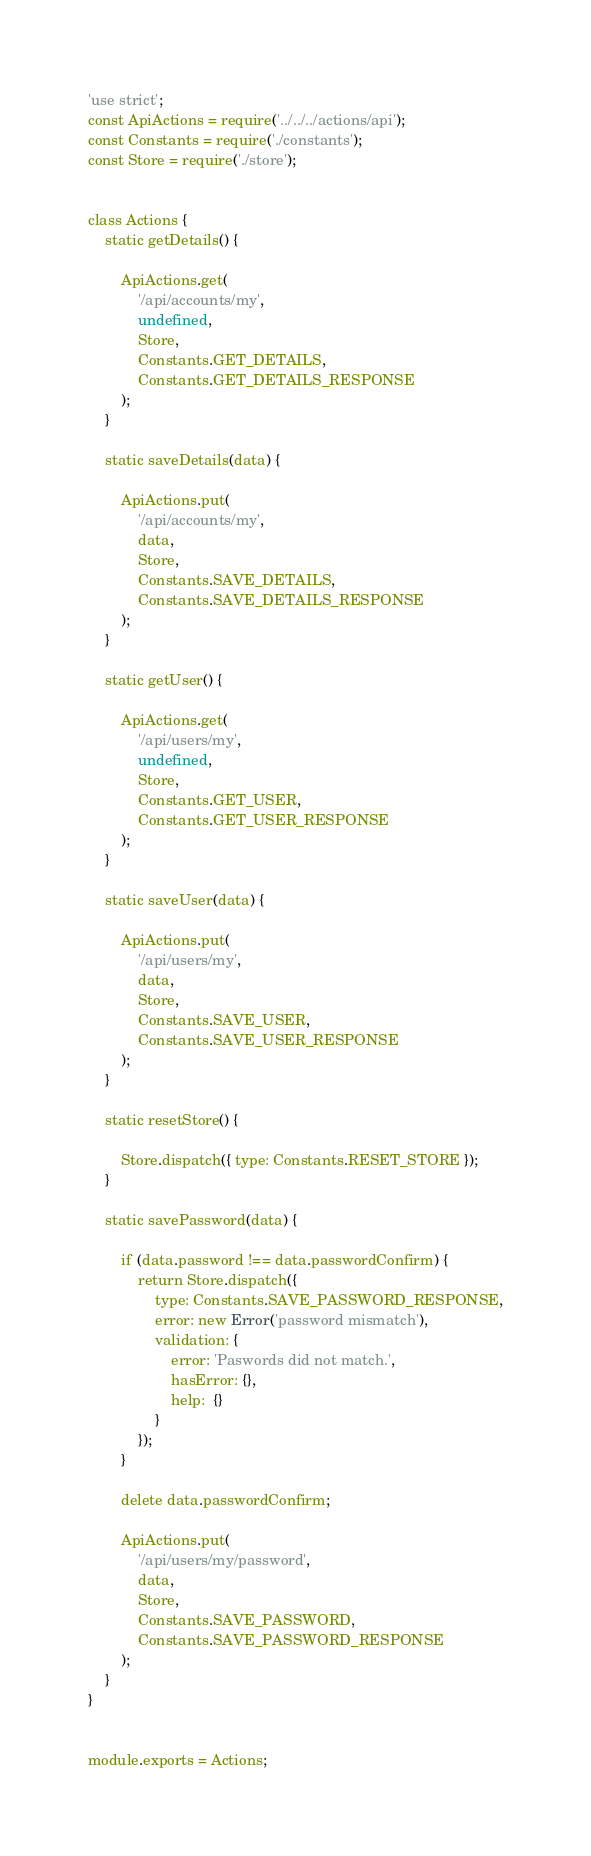Convert code to text. <code><loc_0><loc_0><loc_500><loc_500><_JavaScript_>'use strict';
const ApiActions = require('../../../actions/api');
const Constants = require('./constants');
const Store = require('./store');


class Actions {
    static getDetails() {

        ApiActions.get(
            '/api/accounts/my',
            undefined,
            Store,
            Constants.GET_DETAILS,
            Constants.GET_DETAILS_RESPONSE
        );
    }

    static saveDetails(data) {

        ApiActions.put(
            '/api/accounts/my',
            data,
            Store,
            Constants.SAVE_DETAILS,
            Constants.SAVE_DETAILS_RESPONSE
        );
    }

    static getUser() {

        ApiActions.get(
            '/api/users/my',
            undefined,
            Store,
            Constants.GET_USER,
            Constants.GET_USER_RESPONSE
        );
    }

    static saveUser(data) {

        ApiActions.put(
            '/api/users/my',
            data,
            Store,
            Constants.SAVE_USER,
            Constants.SAVE_USER_RESPONSE
        );
    }

    static resetStore() {

        Store.dispatch({ type: Constants.RESET_STORE });
    }

    static savePassword(data) {

        if (data.password !== data.passwordConfirm) {
            return Store.dispatch({
                type: Constants.SAVE_PASSWORD_RESPONSE,
                error: new Error('password mismatch'),
                validation: {
                    error: 'Paswords did not match.',
                    hasError: {},
                    help:  {}
                }
            });
        }

        delete data.passwordConfirm;

        ApiActions.put(
            '/api/users/my/password',
            data,
            Store,
            Constants.SAVE_PASSWORD,
            Constants.SAVE_PASSWORD_RESPONSE
        );
    }
}


module.exports = Actions;
</code> 